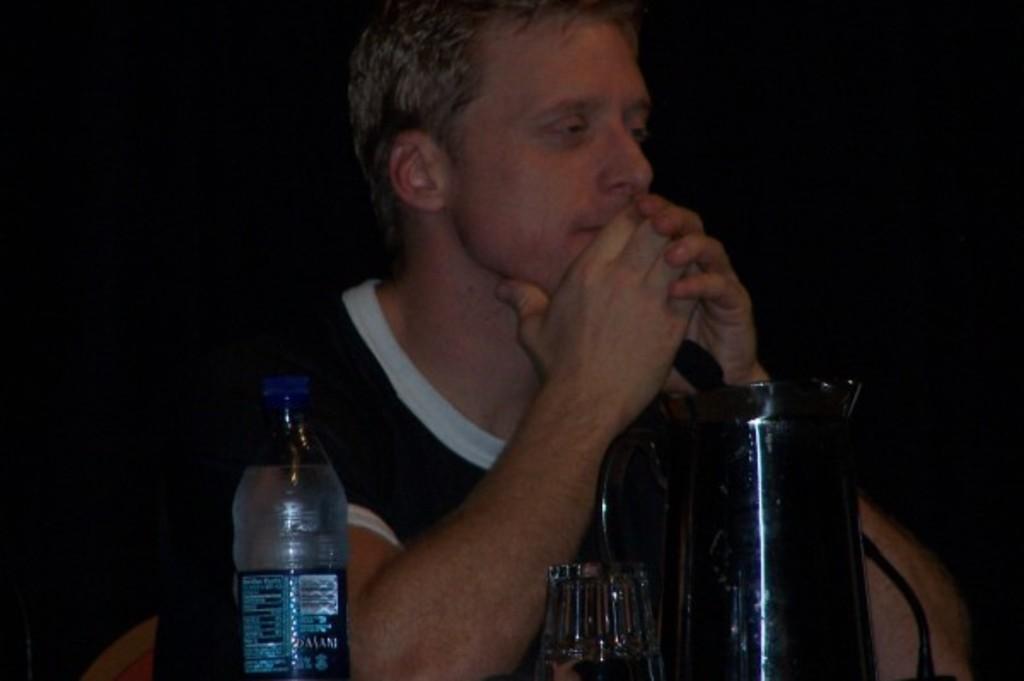Describe this image in one or two sentences. There is a man who is behind jar and there is a water bottle. The man is sitting on chair. 